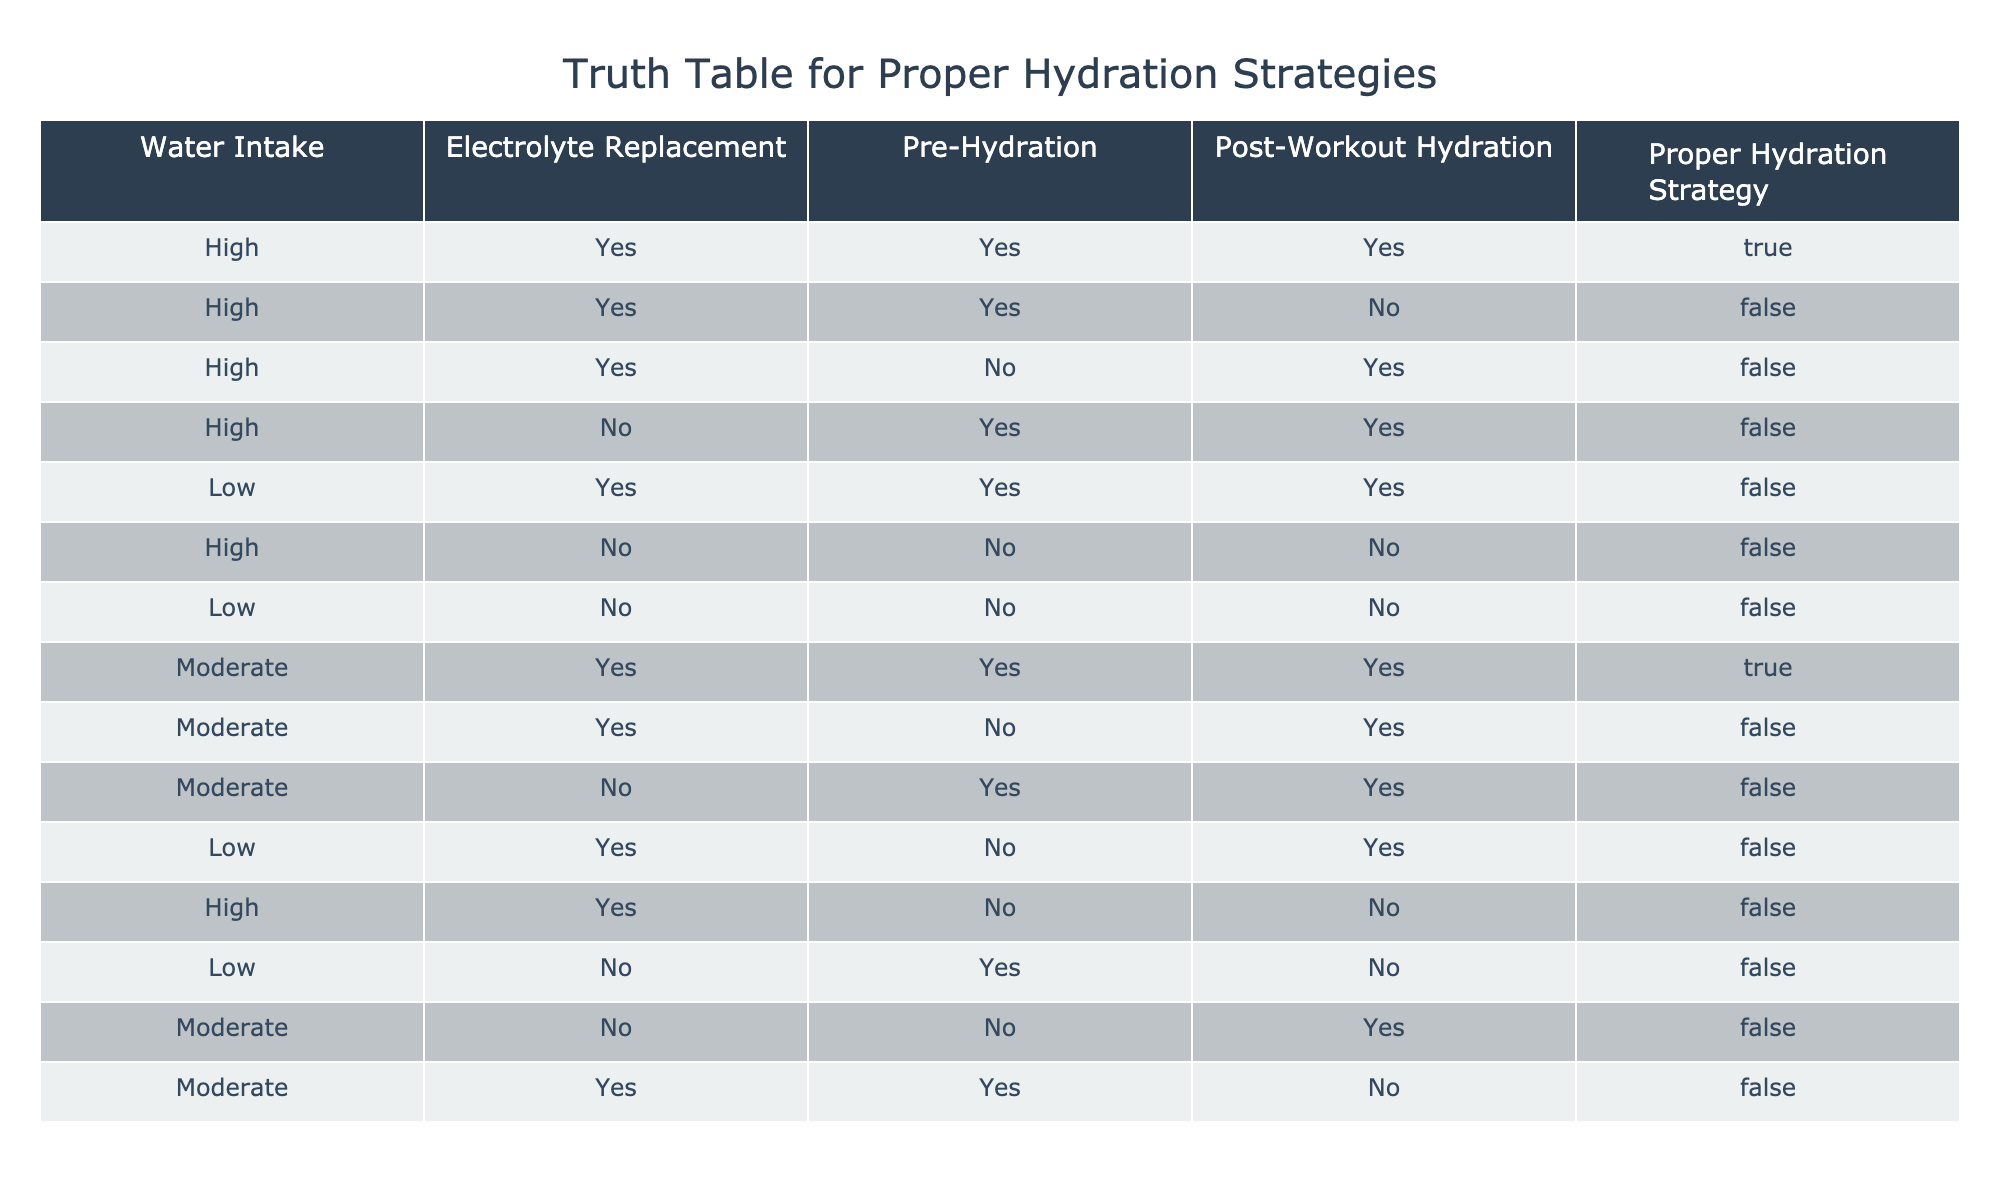What hydration strategy is recommended when water intake is high, electrolytes are replaced, pre-hydration is done, and post-workout hydration is also followed? The table shows that when water intake is high, electrolytes are replaced, pre-hydration is done, and post-workout hydration is also applied, the result is marked as true for a proper hydration strategy.
Answer: True Is it true that low water intake with no electrolyte replacement results in a proper hydration strategy? According to the table, the combination of low water intake and no electrolyte replacement yields a false value for a proper hydration strategy.
Answer: False How many instances indicate a proper hydration strategy when water intake is moderate? There are two instances in the table where water intake is moderate and the result is true for a proper hydration strategy. Counting those rows gives a total of two.
Answer: 2 Are electrolytes required for a proper hydration strategy if water intake is high and pre-hydration is done? The data shows that even if water intake is high and pre-hydration is present, proper hydration requires electrolyte replacement as seen in the corresponding rows. Hence, electrolytes are necessary in such conditions.
Answer: Yes What is the average number of hydration strategies marked as true when water intake is labeled as high? The table identifies one instance of a proper hydration strategy marked as true with high water intake. Therefore, the average is 1, as there’s just one count, divided by the number of entries for high water intake which is four. Hence, 1/4 = 0.25.
Answer: 0.25 What are the conditions that lead to a proper hydration strategy if water intake is low? The table shows that when water intake is low, there are no combinations leading to a true result in the hydration strategy. Hence, no conditions meet the requirements for proper hydration when the water intake is low.
Answer: None How many total rows state that a proper hydration strategy is marked false? To find this, we count the rows labeled false in the last column. There are 10 entries that indicate a false value for a proper hydration strategy.
Answer: 10 If electrolyte replacement is yes and post-workout hydration is no, does that lead to a proper hydration strategy? The table illustrates that with electrolyte replacement as yes and post-workout hydration as no, the status is false for a proper hydration strategy. Therefore, this combination does not result in a proper hydration strategy.
Answer: No 